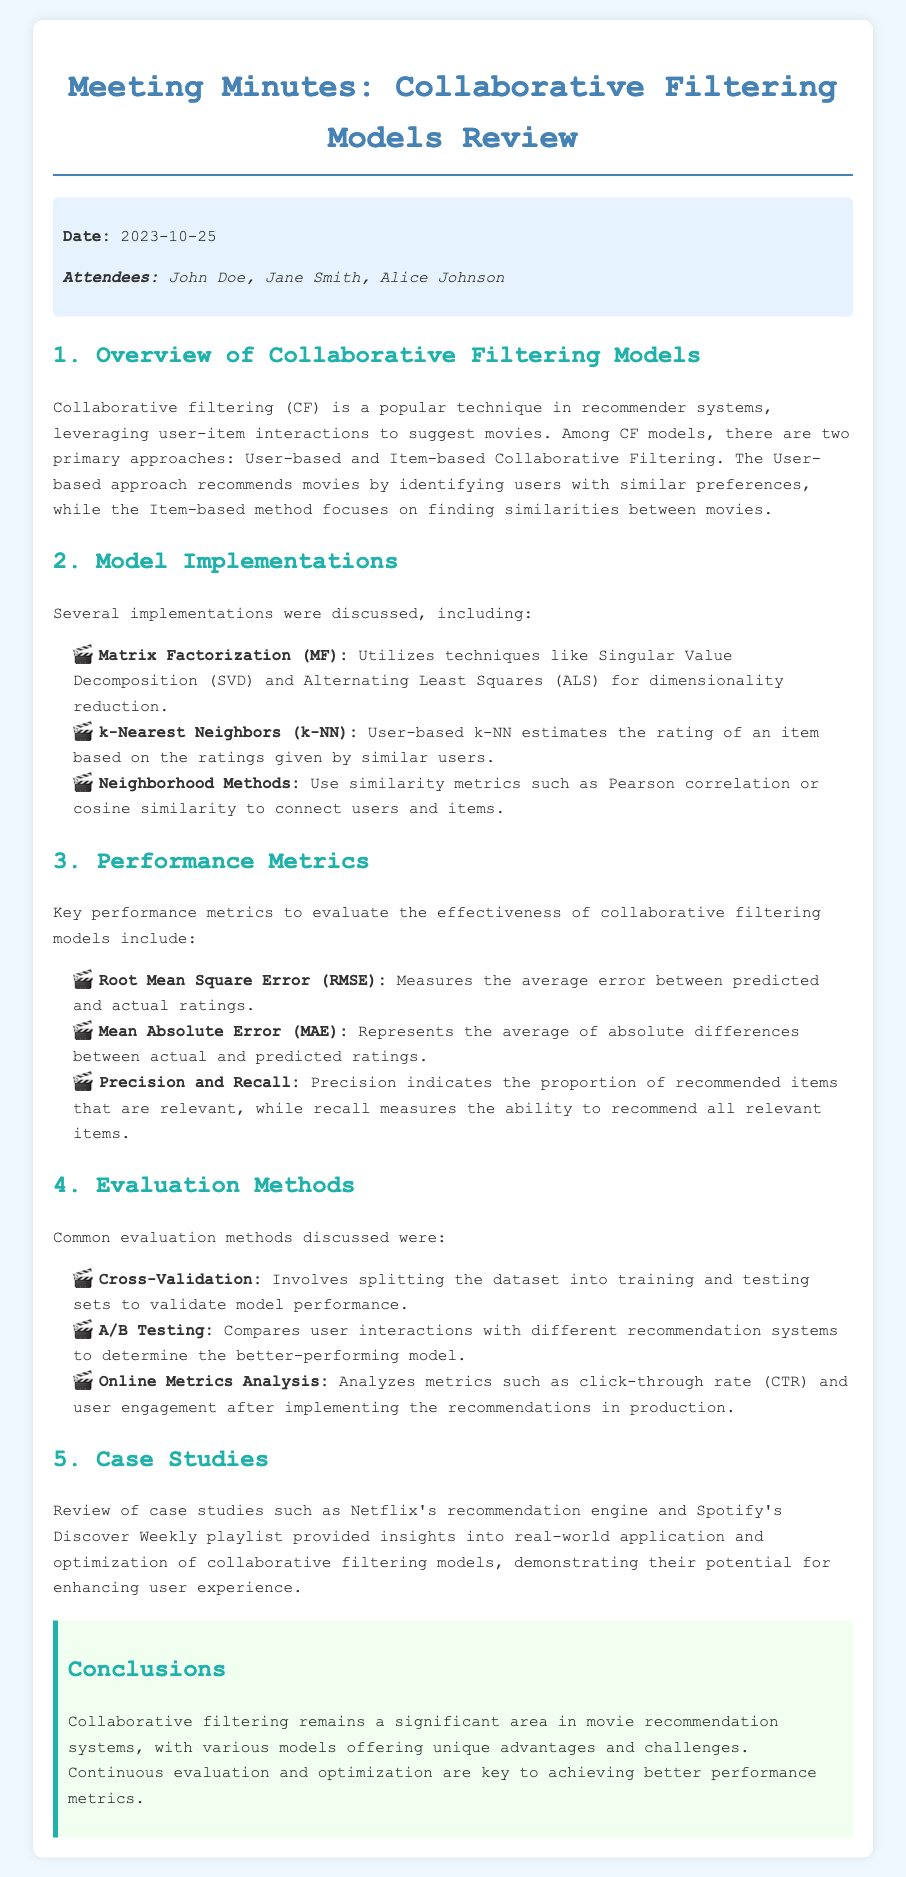What date was the meeting held? The date of the meeting is mentioned in the meta-info section of the document.
Answer: 2023-10-25 Who attended the meeting? The attendees' names are listed in the meta-info section of the document.
Answer: John Doe, Jane Smith, Alice Johnson What is the primary goal of collaborative filtering? The goal is outlined in the overview section, focusing on leveraging user-item interactions for recommendations.
Answer: To suggest movies What performance metric measures the average error between predicted and actual ratings? The document specifies that Root Mean Square Error (RMSE) measures this average error.
Answer: Root Mean Square Error (RMSE) What evaluation method involves splitting the dataset for model validation? The evaluation method discussed in the document that involves this process is cross-validation.
Answer: Cross-Validation What case studies were reviewed in the meeting? The document refers to specific examples of recommendation engines as case studies.
Answer: Netflix's recommendation engine and Spotify's Discover Weekly playlist Which collaborative filtering model utilizes Singular Value Decomposition? The document mentions Matrix Factorization (MF) as a model that uses this technique.
Answer: Matrix Factorization (MF) What does precision measure in the context of collaborative filtering? The document states that precision indicates the proportion of recommended items that are relevant.
Answer: The proportion of recommended items that are relevant What is the primary challenge mentioned regarding collaborative filtering models? The conclusions section highlights continuous evaluation and optimization as key challenges.
Answer: Continuous evaluation and optimization 